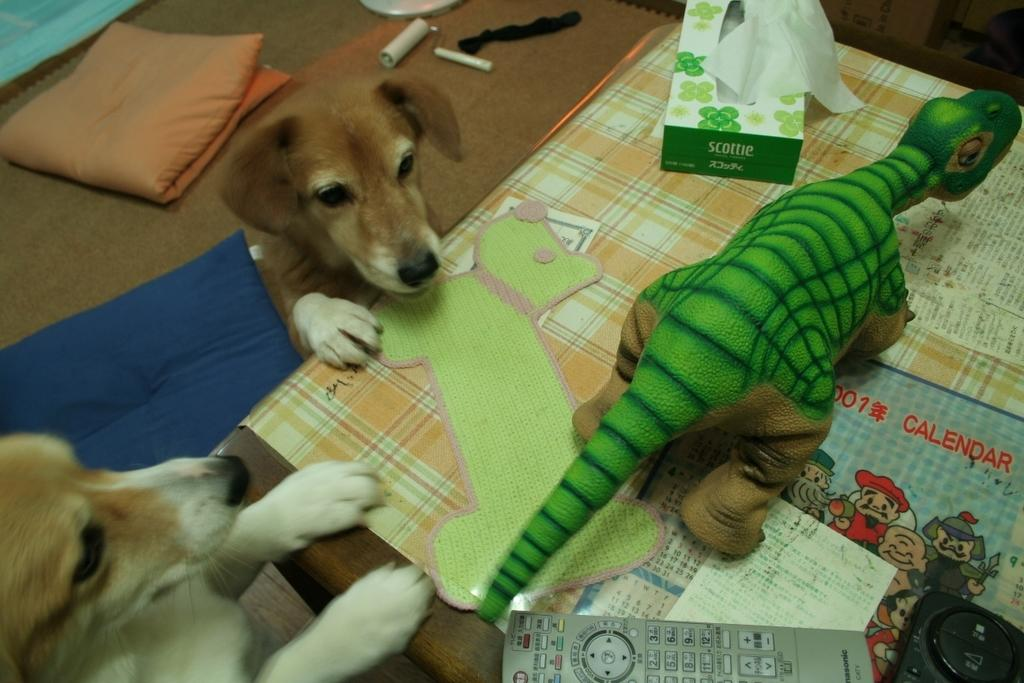What animals are on the left side of the image? There are two dogs on the left side of the image. What object is on the right side of the image? There is a doll on the right side of the image. What device is at the bottom of the image? There is a remote at the bottom of the image. What item is at the top of the image? There are tissues at the top of the image. What type of seed is being planted by the dogs in the image? There are no seeds or planting activities depicted in the image; it features two dogs, a doll, a remote, and tissues. Who is the representative of the dogs in the image? There is no representative present in the image; it simply shows two dogs. 